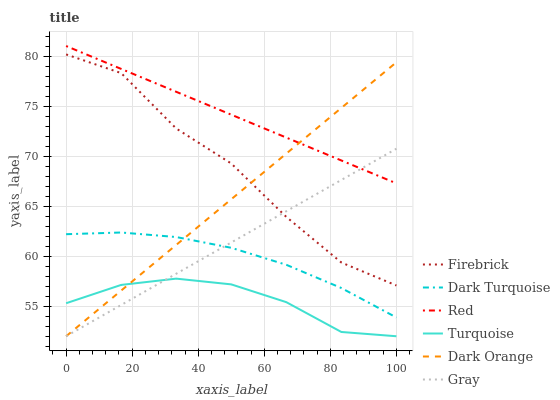Does Turquoise have the minimum area under the curve?
Answer yes or no. Yes. Does Red have the maximum area under the curve?
Answer yes or no. Yes. Does Dark Orange have the minimum area under the curve?
Answer yes or no. No. Does Dark Orange have the maximum area under the curve?
Answer yes or no. No. Is Red the smoothest?
Answer yes or no. Yes. Is Firebrick the roughest?
Answer yes or no. Yes. Is Turquoise the smoothest?
Answer yes or no. No. Is Turquoise the roughest?
Answer yes or no. No. Does Gray have the lowest value?
Answer yes or no. Yes. Does Dark Turquoise have the lowest value?
Answer yes or no. No. Does Red have the highest value?
Answer yes or no. Yes. Does Dark Orange have the highest value?
Answer yes or no. No. Is Turquoise less than Red?
Answer yes or no. Yes. Is Firebrick greater than Dark Turquoise?
Answer yes or no. Yes. Does Dark Turquoise intersect Gray?
Answer yes or no. Yes. Is Dark Turquoise less than Gray?
Answer yes or no. No. Is Dark Turquoise greater than Gray?
Answer yes or no. No. Does Turquoise intersect Red?
Answer yes or no. No. 